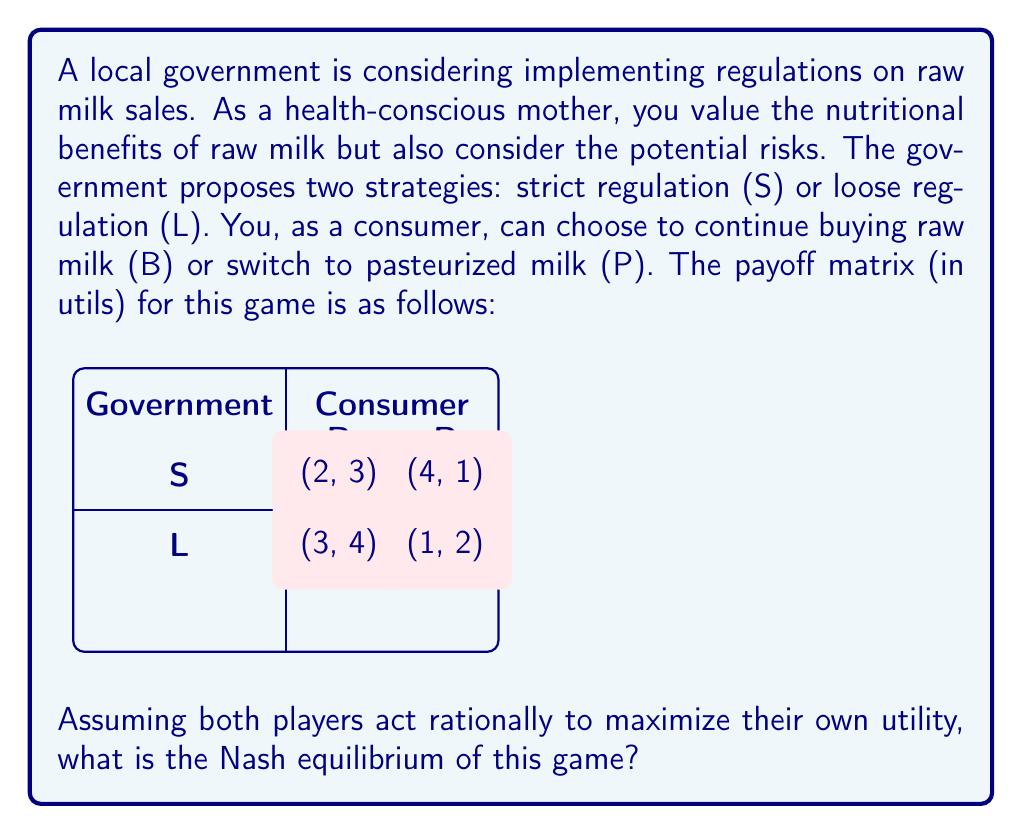Show me your answer to this math problem. To find the Nash equilibrium, we need to analyze each player's best response to the other player's strategy:

1. Consumer's perspective:
   - If Government chooses S: B (3) > P (1), so B is best response
   - If Government chooses L: B (4) > P (2), so B is best response

2. Government's perspective:
   - If Consumer chooses B: L (3) > S (2), so L is best response
   - If Consumer chooses P: S (4) > L (1), so S is best response

3. Nash equilibrium occurs when both players are playing their best response to the other's strategy.

4. From the analysis, we can see that when:
   - Government plays L
   - Consumer plays B
   Both players are playing their best response to the other's strategy.

5. Therefore, the Nash equilibrium is (L, B) with payoffs (3, 4).

This equilibrium suggests that under loose regulations, the health-conscious mother (consumer) would continue buying raw milk, maximizing her perceived benefits while the government maintains a balance between consumer freedom and safety concerns.
Answer: (L, B) 